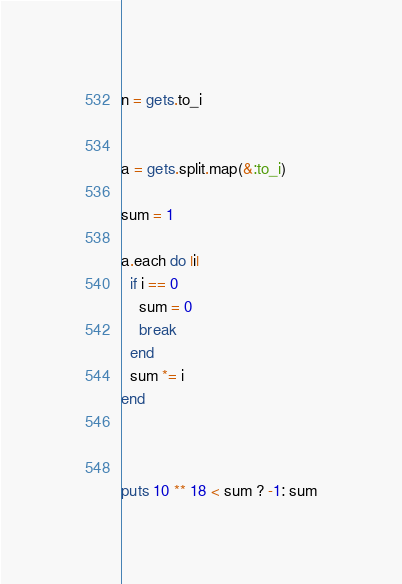<code> <loc_0><loc_0><loc_500><loc_500><_Ruby_>n = gets.to_i


a = gets.split.map(&:to_i)

sum = 1

a.each do |i|
  if i == 0
    sum = 0
    break
  end
  sum *= i
end



puts 10 ** 18 < sum ? -1: sum</code> 